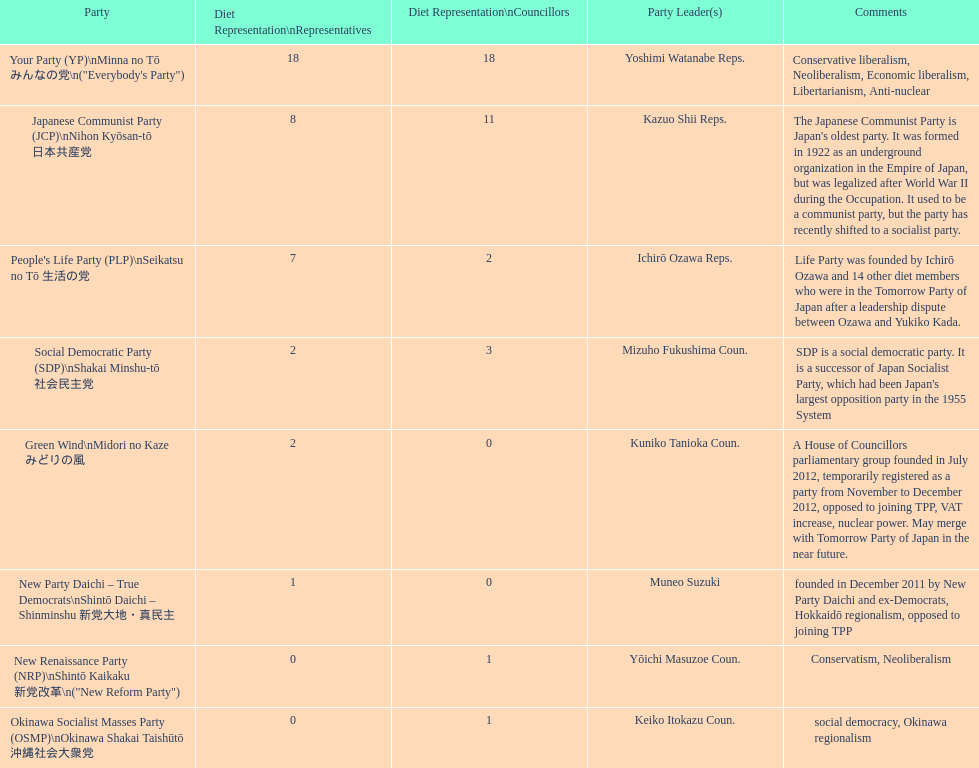As per this table, which party is japan's longest-standing political party? Japanese Communist Party (JCP) Nihon Kyōsan-tō 日本共産党. Parse the table in full. {'header': ['Party', 'Diet Representation\\nRepresentatives', 'Diet Representation\\nCouncillors', 'Party Leader(s)', 'Comments'], 'rows': [['Your Party (YP)\\nMinna no Tō みんなの党\\n("Everybody\'s Party")', '18', '18', 'Yoshimi Watanabe Reps.', 'Conservative liberalism, Neoliberalism, Economic liberalism, Libertarianism, Anti-nuclear'], ['Japanese Communist Party (JCP)\\nNihon Kyōsan-tō 日本共産党', '8', '11', 'Kazuo Shii Reps.', "The Japanese Communist Party is Japan's oldest party. It was formed in 1922 as an underground organization in the Empire of Japan, but was legalized after World War II during the Occupation. It used to be a communist party, but the party has recently shifted to a socialist party."], ["People's Life Party (PLP)\\nSeikatsu no Tō 生活の党", '7', '2', 'Ichirō Ozawa Reps.', 'Life Party was founded by Ichirō Ozawa and 14 other diet members who were in the Tomorrow Party of Japan after a leadership dispute between Ozawa and Yukiko Kada.'], ['Social Democratic Party (SDP)\\nShakai Minshu-tō 社会民主党', '2', '3', 'Mizuho Fukushima Coun.', "SDP is a social democratic party. It is a successor of Japan Socialist Party, which had been Japan's largest opposition party in the 1955 System"], ['Green Wind\\nMidori no Kaze みどりの風', '2', '0', 'Kuniko Tanioka Coun.', 'A House of Councillors parliamentary group founded in July 2012, temporarily registered as a party from November to December 2012, opposed to joining TPP, VAT increase, nuclear power. May merge with Tomorrow Party of Japan in the near future.'], ['New Party Daichi – True Democrats\\nShintō Daichi – Shinminshu 新党大地・真民主', '1', '0', 'Muneo Suzuki', 'founded in December 2011 by New Party Daichi and ex-Democrats, Hokkaidō regionalism, opposed to joining TPP'], ['New Renaissance Party (NRP)\\nShintō Kaikaku 新党改革\\n("New Reform Party")', '0', '1', 'Yōichi Masuzoe Coun.', 'Conservatism, Neoliberalism'], ['Okinawa Socialist Masses Party (OSMP)\\nOkinawa Shakai Taishūtō 沖縄社会大衆党', '0', '1', 'Keiko Itokazu Coun.', 'social democracy, Okinawa regionalism']]} 